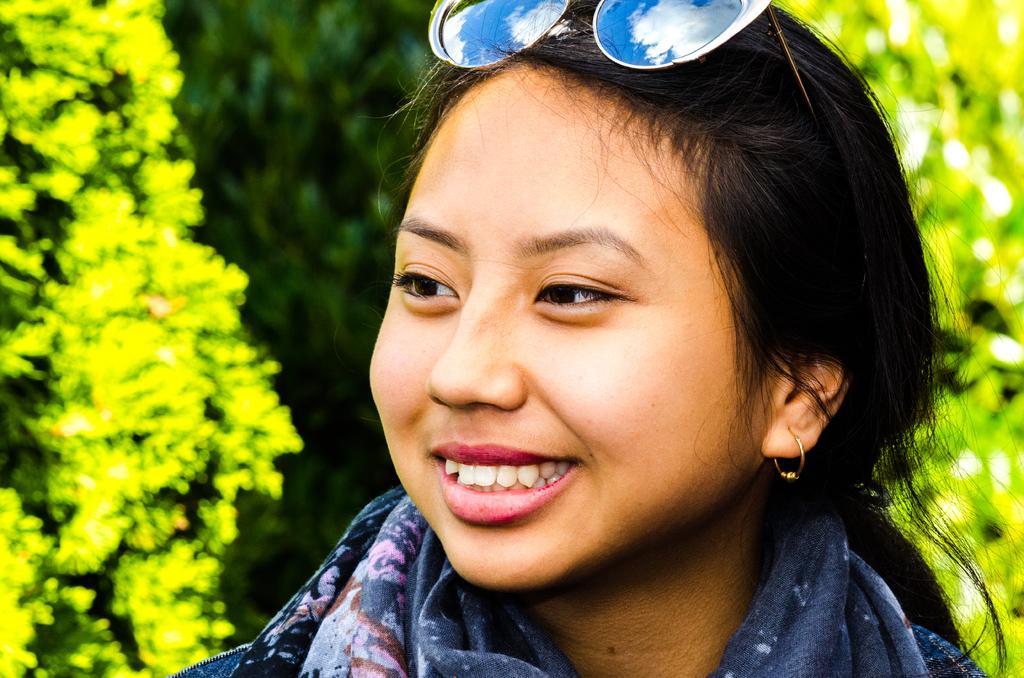Describe this image in one or two sentences. In this image in the foreground there is one woman who is wearing goggles, and in the background there are some trees. 